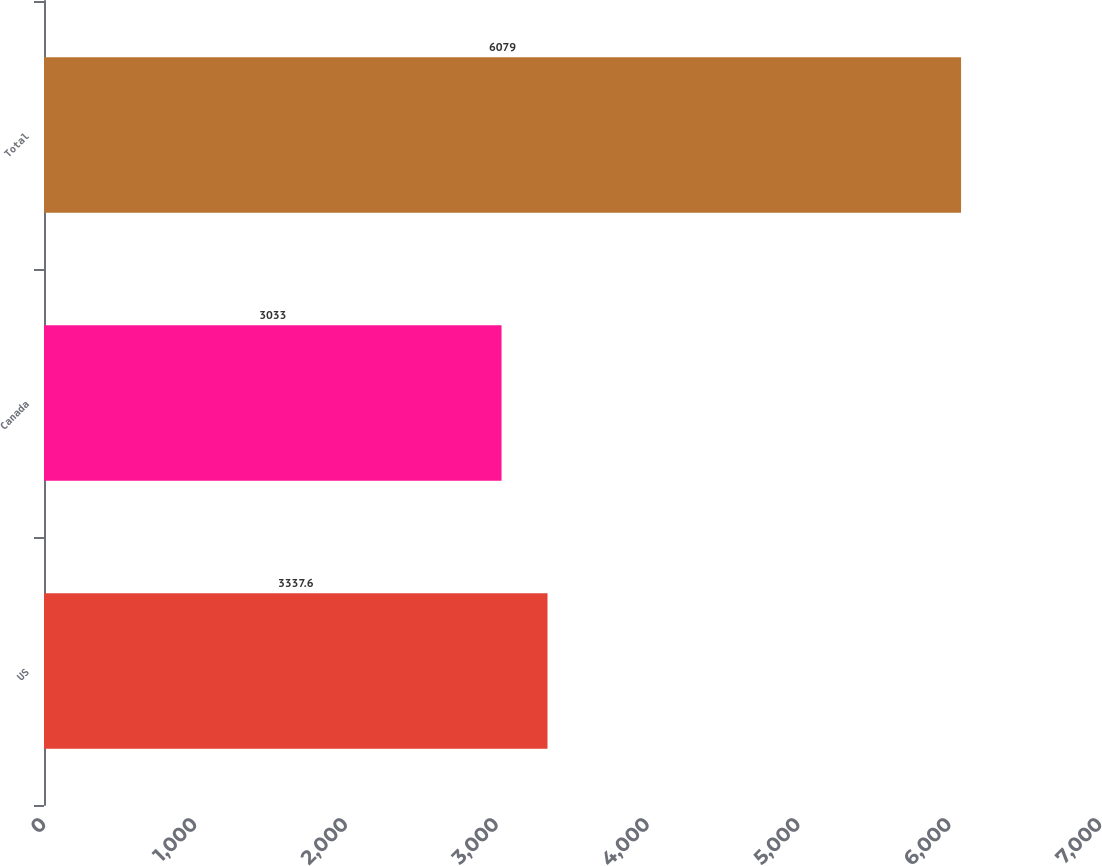Convert chart. <chart><loc_0><loc_0><loc_500><loc_500><bar_chart><fcel>US<fcel>Canada<fcel>Total<nl><fcel>3337.6<fcel>3033<fcel>6079<nl></chart> 